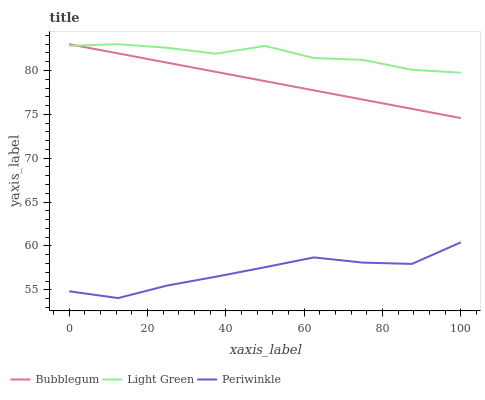Does Periwinkle have the minimum area under the curve?
Answer yes or no. Yes. Does Light Green have the maximum area under the curve?
Answer yes or no. Yes. Does Bubblegum have the minimum area under the curve?
Answer yes or no. No. Does Bubblegum have the maximum area under the curve?
Answer yes or no. No. Is Bubblegum the smoothest?
Answer yes or no. Yes. Is Light Green the roughest?
Answer yes or no. Yes. Is Light Green the smoothest?
Answer yes or no. No. Is Bubblegum the roughest?
Answer yes or no. No. Does Periwinkle have the lowest value?
Answer yes or no. Yes. Does Bubblegum have the lowest value?
Answer yes or no. No. Does Bubblegum have the highest value?
Answer yes or no. Yes. Is Periwinkle less than Bubblegum?
Answer yes or no. Yes. Is Bubblegum greater than Periwinkle?
Answer yes or no. Yes. Does Light Green intersect Bubblegum?
Answer yes or no. Yes. Is Light Green less than Bubblegum?
Answer yes or no. No. Is Light Green greater than Bubblegum?
Answer yes or no. No. Does Periwinkle intersect Bubblegum?
Answer yes or no. No. 